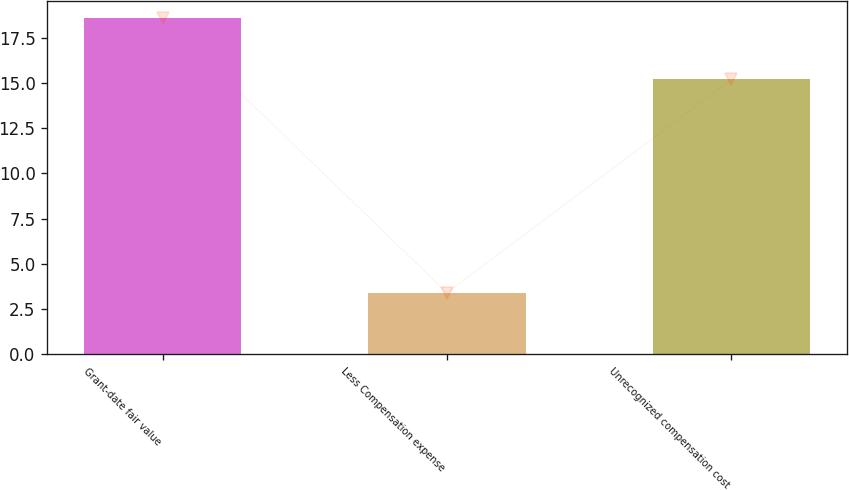<chart> <loc_0><loc_0><loc_500><loc_500><bar_chart><fcel>Grant-date fair value<fcel>Less Compensation expense<fcel>Unrecognized compensation cost<nl><fcel>18.6<fcel>3.4<fcel>15.2<nl></chart> 